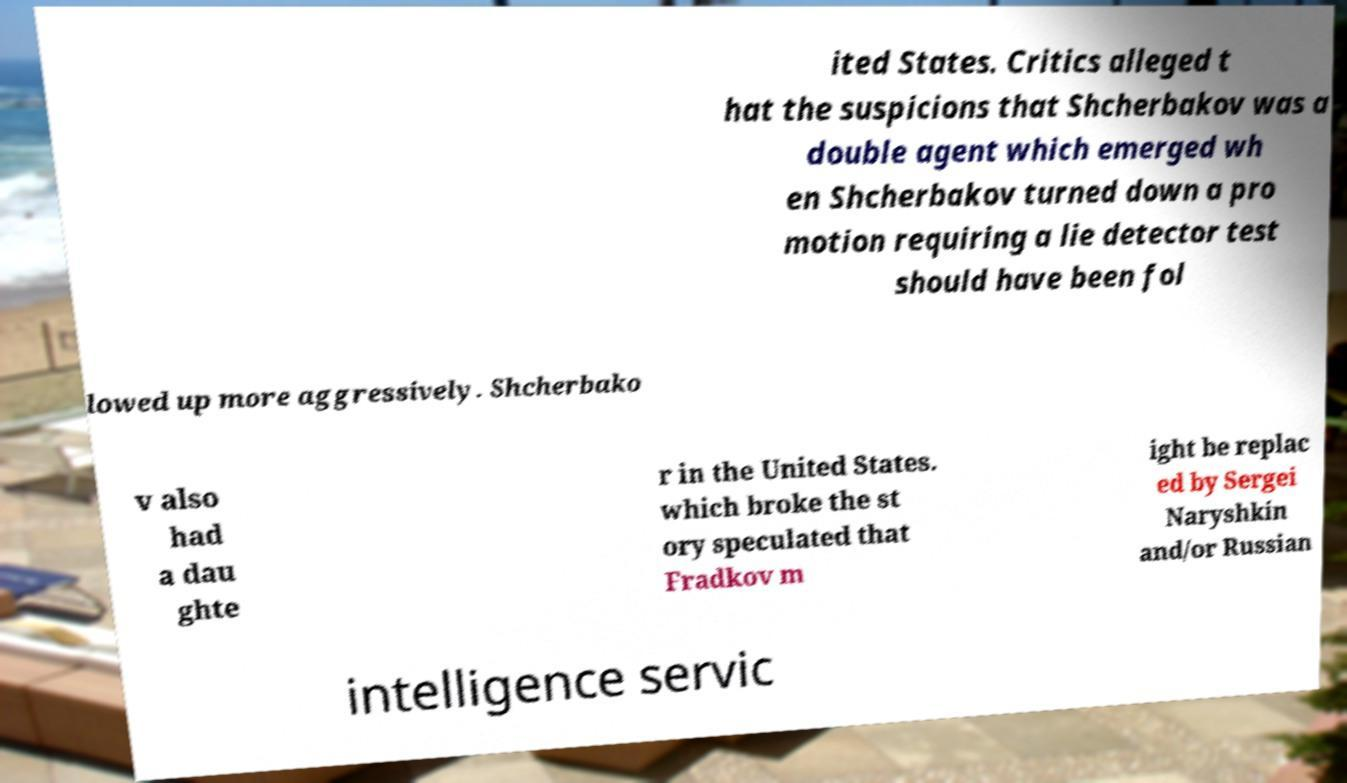Please read and relay the text visible in this image. What does it say? ited States. Critics alleged t hat the suspicions that Shcherbakov was a double agent which emerged wh en Shcherbakov turned down a pro motion requiring a lie detector test should have been fol lowed up more aggressively. Shcherbako v also had a dau ghte r in the United States. which broke the st ory speculated that Fradkov m ight be replac ed by Sergei Naryshkin and/or Russian intelligence servic 